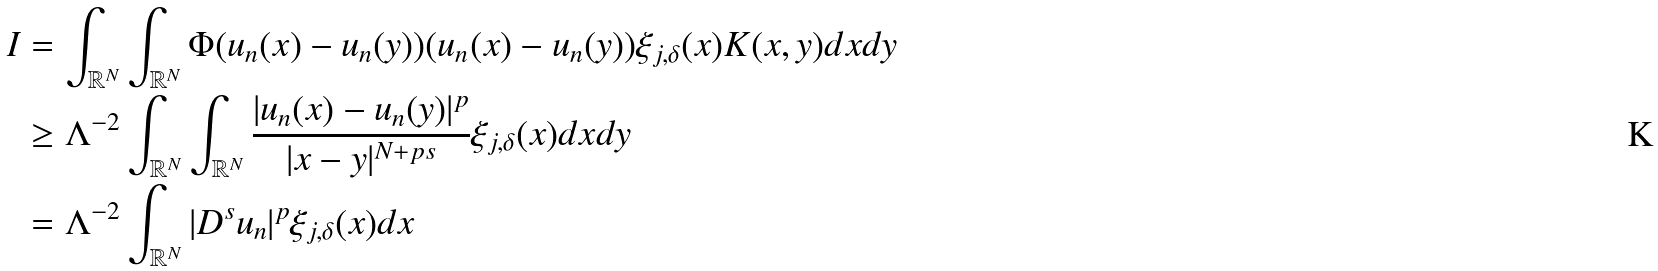<formula> <loc_0><loc_0><loc_500><loc_500>I & = \int _ { \mathbb { R } ^ { N } } \int _ { \mathbb { R } ^ { N } } \Phi ( u _ { n } ( x ) - u _ { n } ( y ) ) ( u _ { n } ( x ) - u _ { n } ( y ) ) \xi _ { j , \delta } ( x ) K ( x , y ) d x d y \\ & \geq \Lambda ^ { - 2 } \int _ { \mathbb { R } ^ { N } } \int _ { \mathbb { R } ^ { N } } \frac { | u _ { n } ( x ) - u _ { n } ( y ) | ^ { p } } { | x - y | ^ { N + p s } } \xi _ { j , \delta } ( x ) d x d y \\ & = \Lambda ^ { - 2 } \int _ { \mathbb { R } ^ { N } } | D ^ { s } u _ { n } | ^ { p } \xi _ { j , \delta } ( x ) d x</formula> 